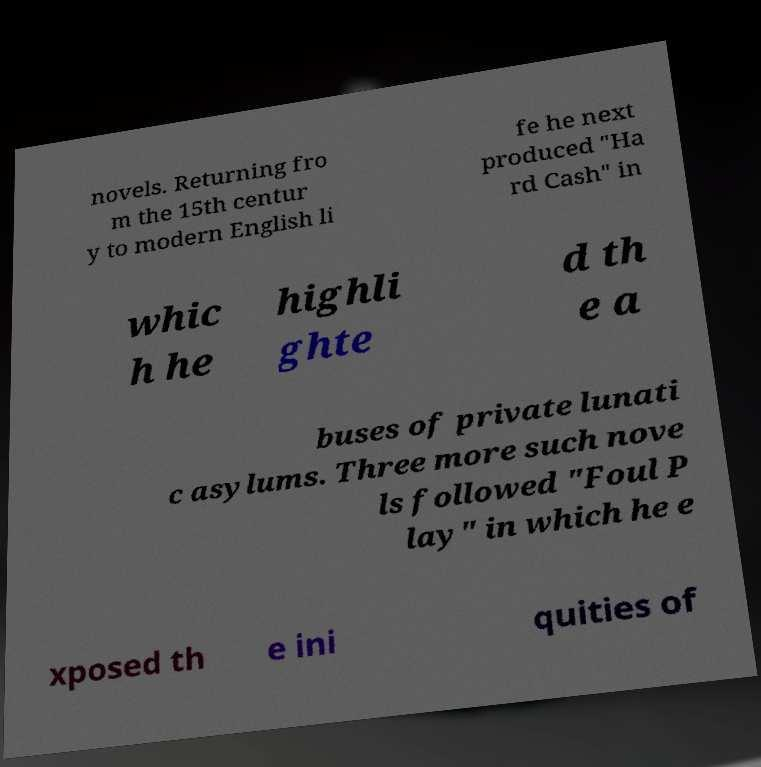Can you read and provide the text displayed in the image?This photo seems to have some interesting text. Can you extract and type it out for me? novels. Returning fro m the 15th centur y to modern English li fe he next produced "Ha rd Cash" in whic h he highli ghte d th e a buses of private lunati c asylums. Three more such nove ls followed "Foul P lay" in which he e xposed th e ini quities of 